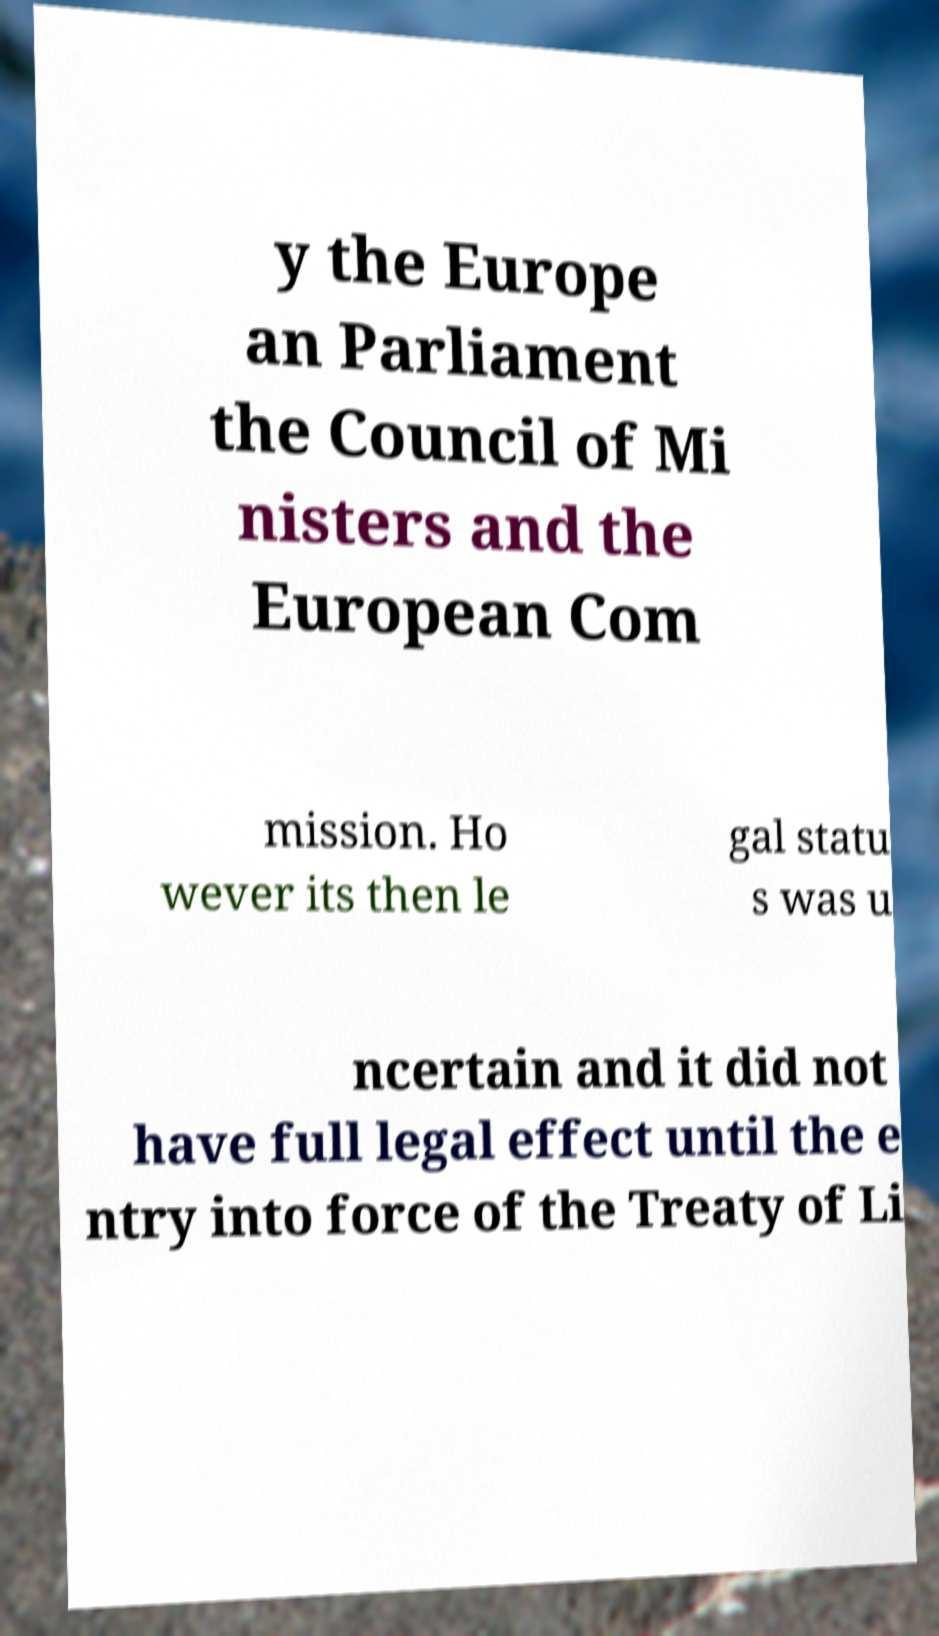What messages or text are displayed in this image? I need them in a readable, typed format. y the Europe an Parliament the Council of Mi nisters and the European Com mission. Ho wever its then le gal statu s was u ncertain and it did not have full legal effect until the e ntry into force of the Treaty of Li 